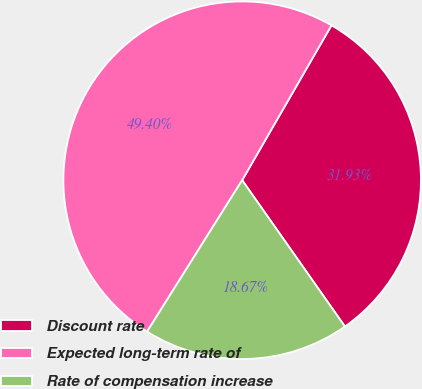Convert chart to OTSL. <chart><loc_0><loc_0><loc_500><loc_500><pie_chart><fcel>Discount rate<fcel>Expected long-term rate of<fcel>Rate of compensation increase<nl><fcel>31.93%<fcel>49.4%<fcel>18.67%<nl></chart> 